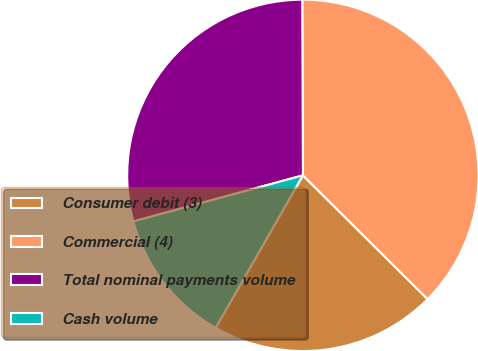Convert chart. <chart><loc_0><loc_0><loc_500><loc_500><pie_chart><fcel>Consumer debit (3)<fcel>Commercial (4)<fcel>Total nominal payments volume<fcel>Cash volume<nl><fcel>20.83%<fcel>37.5%<fcel>29.17%<fcel>12.5%<nl></chart> 